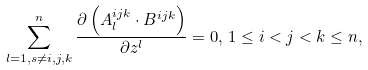<formula> <loc_0><loc_0><loc_500><loc_500>\sum _ { l = 1 , s \neq i , j , k } ^ { n } \frac { \partial \left ( A _ { l } ^ { i j k } \cdot B ^ { i j k } \right ) } { \partial z ^ { l } } = 0 , \, 1 \leq i < j < k \leq n ,</formula> 